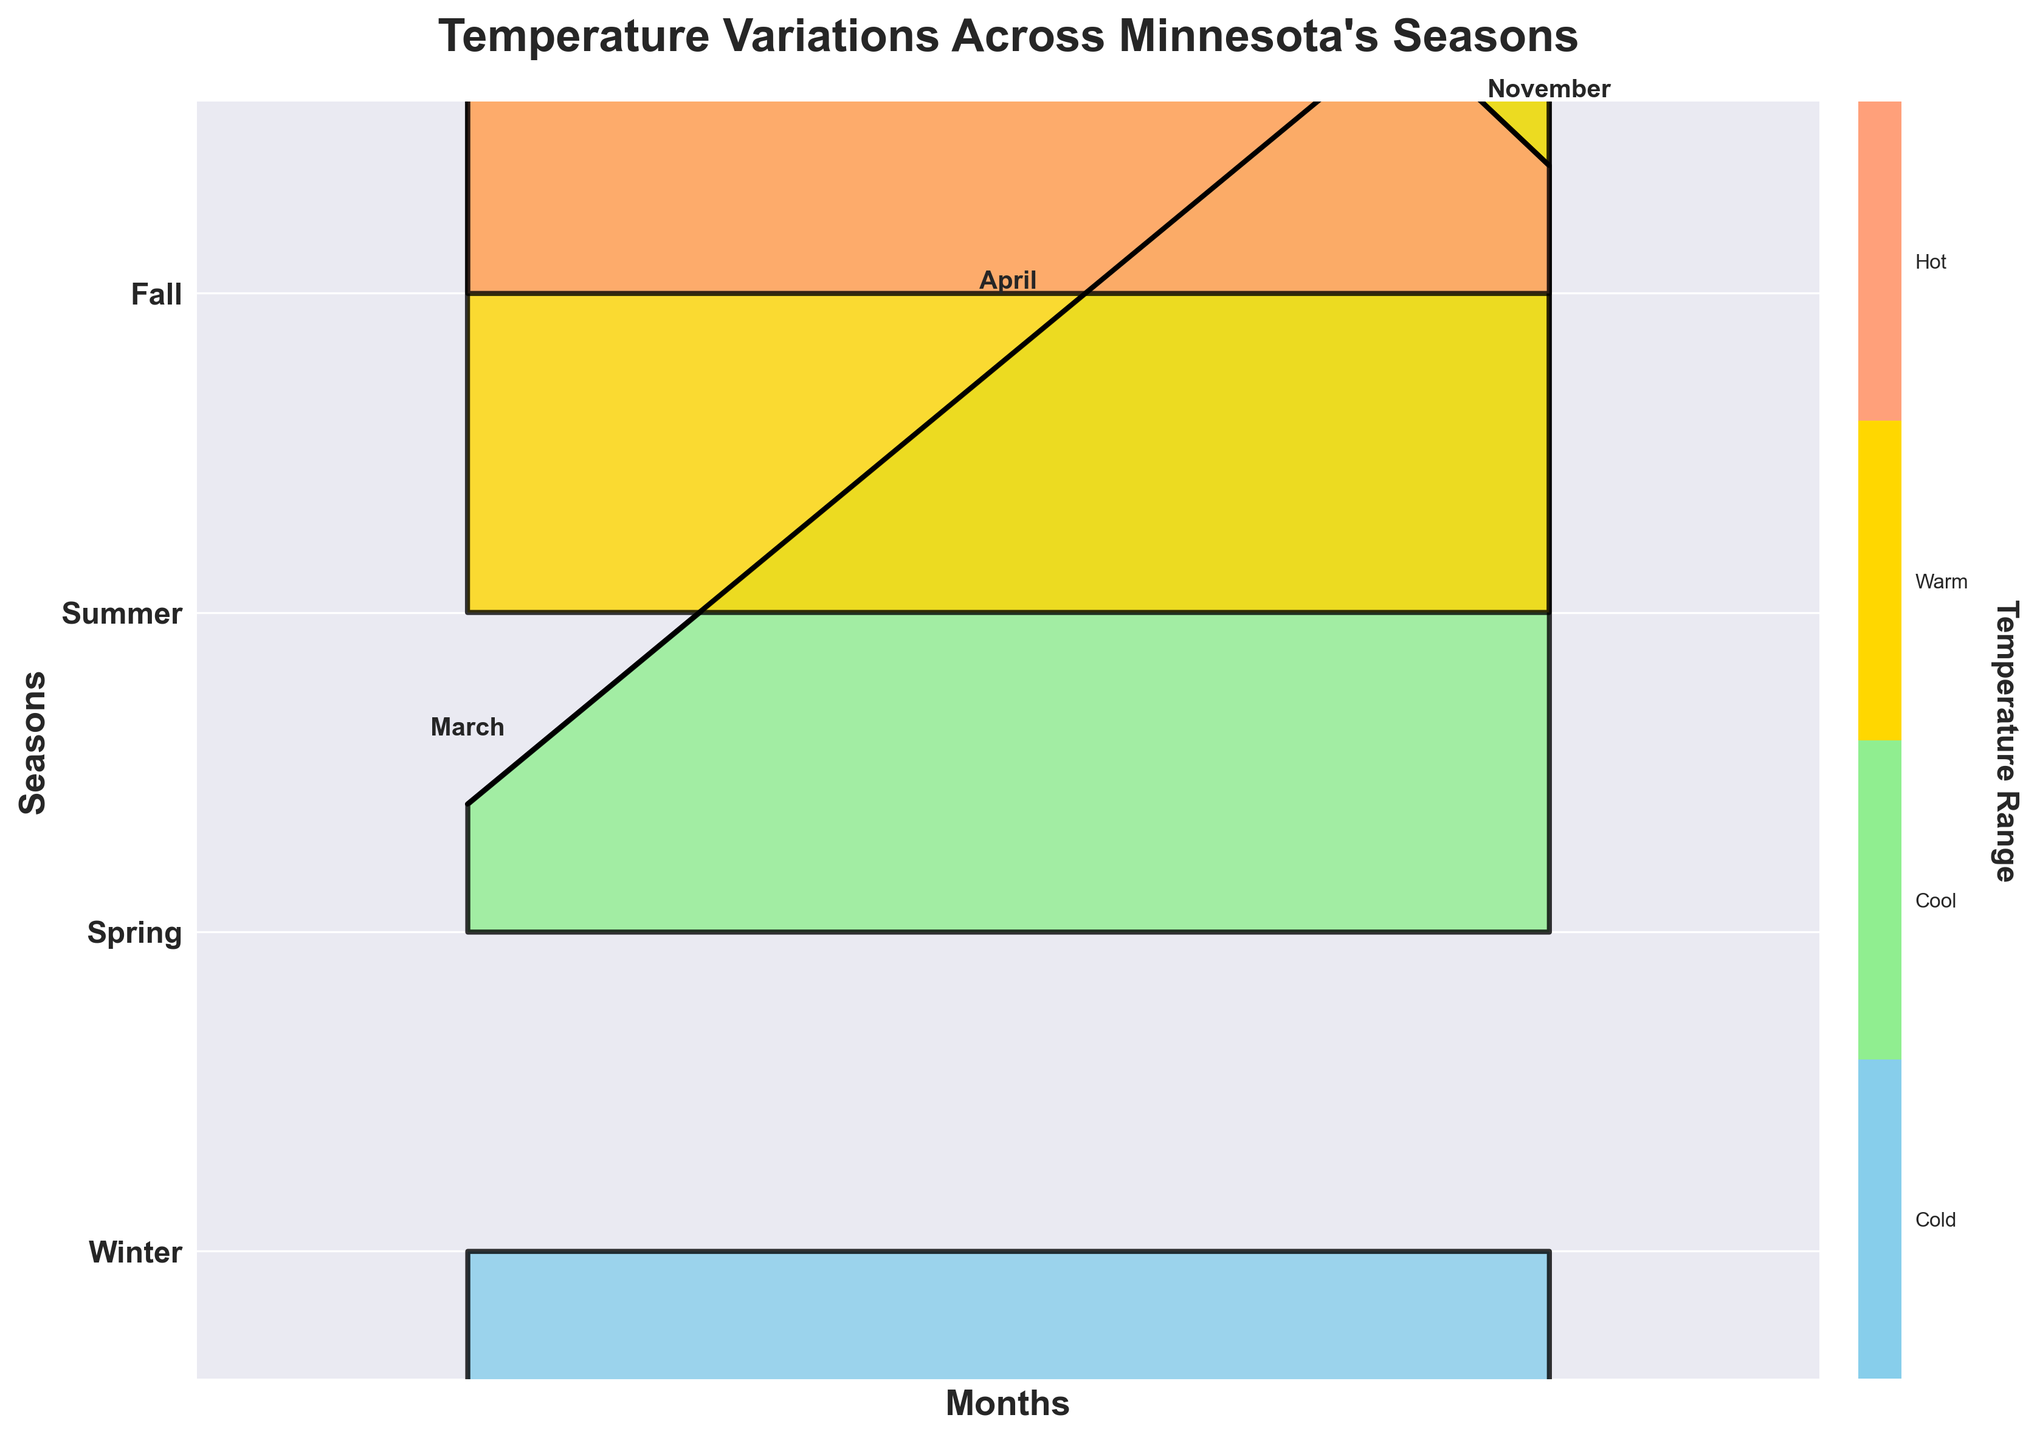What is the title of the plot? The title is located at the top of the figure and it provides a brief description of what the figure represents. It reads "Temperature Variations Across Minnesota's Seasons".
Answer: Temperature Variations Across Minnesota's Seasons How many distinct seasons are represented in the plot? The plot uses different color bands for each season, which are labeled on the y-axis. By counting these labels, we see there are four distinct seasons: Winter, Spring, Summer, and Fall.
Answer: 4 Which season has the highest temperature, and what is that temperature? By observing the uppermost peak on the plot, we can see that Summer has the highest temperature, as indicated by the highest point in the Summer color band. The highest temperature is 24°C in July.
Answer: Summer, 24°C What is the color representation of Winter in the plot? Winter is represented by a specific color band on the Ridgeline plot. This color is a light blue, which can be confirmed by looking at the fill color used for December, January, and February.
Answer: Light blue In which month does the temperature start to become positive in Spring? The temperature becomes positive in Spring starting from March. This can be read from the labels on the x-axis for the Spring color band where the first positive temperature appears.
Answer: March What is the temperature difference between January (Winter) and July (Summer)? From the plot, January's temperature is -8°C and July's is 24°C. The difference can be calculated as 24 - (-8) = 32°C.
Answer: 32°C Which season shows the largest temperature change between its beginning and end, and what is that change? By comparing the difference between the highest and lowest temperature in each season's color band, we see that Winter has the largest change, going from -8°C in January to -5°C in December, so the change is -8 - (-5) = 3°C.
Answer: Winter, 3°C How does the temperature in November compare to March? Both November (Fall) and March (Spring) have temperatures marked on the plot. By observing these points, we see that both have a temperature of 2°C, making them equal.
Answer: Equal (2°C) How does the temperature in December compare to that in April? Looking at the December point in Winter and the April point in Spring, December has -5°C while April has 9°C. April is warmer by 9 - (-5) = 14°C.
Answer: April is warmer by 14°C What months are labeled in the Fall season on the plot? The Fall color band on the plot includes three labeled months: September, October, and November, as indicated by the labels along the x-axis for that season.
Answer: September, October, November 